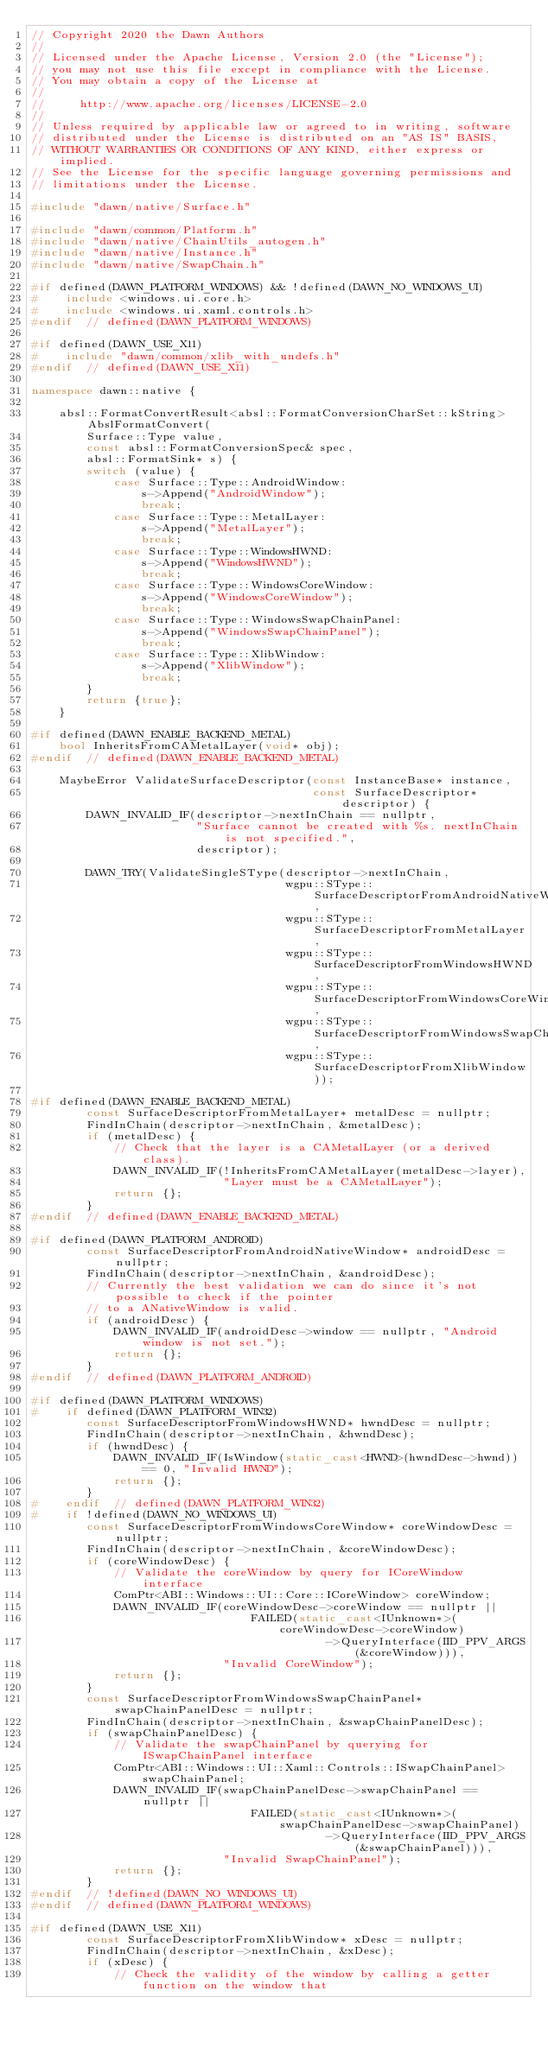Convert code to text. <code><loc_0><loc_0><loc_500><loc_500><_C++_>// Copyright 2020 the Dawn Authors
//
// Licensed under the Apache License, Version 2.0 (the "License");
// you may not use this file except in compliance with the License.
// You may obtain a copy of the License at
//
//     http://www.apache.org/licenses/LICENSE-2.0
//
// Unless required by applicable law or agreed to in writing, software
// distributed under the License is distributed on an "AS IS" BASIS,
// WITHOUT WARRANTIES OR CONDITIONS OF ANY KIND, either express or implied.
// See the License for the specific language governing permissions and
// limitations under the License.

#include "dawn/native/Surface.h"

#include "dawn/common/Platform.h"
#include "dawn/native/ChainUtils_autogen.h"
#include "dawn/native/Instance.h"
#include "dawn/native/SwapChain.h"

#if defined(DAWN_PLATFORM_WINDOWS) && !defined(DAWN_NO_WINDOWS_UI)
#    include <windows.ui.core.h>
#    include <windows.ui.xaml.controls.h>
#endif  // defined(DAWN_PLATFORM_WINDOWS)

#if defined(DAWN_USE_X11)
#    include "dawn/common/xlib_with_undefs.h"
#endif  // defined(DAWN_USE_X11)

namespace dawn::native {

    absl::FormatConvertResult<absl::FormatConversionCharSet::kString> AbslFormatConvert(
        Surface::Type value,
        const absl::FormatConversionSpec& spec,
        absl::FormatSink* s) {
        switch (value) {
            case Surface::Type::AndroidWindow:
                s->Append("AndroidWindow");
                break;
            case Surface::Type::MetalLayer:
                s->Append("MetalLayer");
                break;
            case Surface::Type::WindowsHWND:
                s->Append("WindowsHWND");
                break;
            case Surface::Type::WindowsCoreWindow:
                s->Append("WindowsCoreWindow");
                break;
            case Surface::Type::WindowsSwapChainPanel:
                s->Append("WindowsSwapChainPanel");
                break;
            case Surface::Type::XlibWindow:
                s->Append("XlibWindow");
                break;
        }
        return {true};
    }

#if defined(DAWN_ENABLE_BACKEND_METAL)
    bool InheritsFromCAMetalLayer(void* obj);
#endif  // defined(DAWN_ENABLE_BACKEND_METAL)

    MaybeError ValidateSurfaceDescriptor(const InstanceBase* instance,
                                         const SurfaceDescriptor* descriptor) {
        DAWN_INVALID_IF(descriptor->nextInChain == nullptr,
                        "Surface cannot be created with %s. nextInChain is not specified.",
                        descriptor);

        DAWN_TRY(ValidateSingleSType(descriptor->nextInChain,
                                     wgpu::SType::SurfaceDescriptorFromAndroidNativeWindow,
                                     wgpu::SType::SurfaceDescriptorFromMetalLayer,
                                     wgpu::SType::SurfaceDescriptorFromWindowsHWND,
                                     wgpu::SType::SurfaceDescriptorFromWindowsCoreWindow,
                                     wgpu::SType::SurfaceDescriptorFromWindowsSwapChainPanel,
                                     wgpu::SType::SurfaceDescriptorFromXlibWindow));

#if defined(DAWN_ENABLE_BACKEND_METAL)
        const SurfaceDescriptorFromMetalLayer* metalDesc = nullptr;
        FindInChain(descriptor->nextInChain, &metalDesc);
        if (metalDesc) {
            // Check that the layer is a CAMetalLayer (or a derived class).
            DAWN_INVALID_IF(!InheritsFromCAMetalLayer(metalDesc->layer),
                            "Layer must be a CAMetalLayer");
            return {};
        }
#endif  // defined(DAWN_ENABLE_BACKEND_METAL)

#if defined(DAWN_PLATFORM_ANDROID)
        const SurfaceDescriptorFromAndroidNativeWindow* androidDesc = nullptr;
        FindInChain(descriptor->nextInChain, &androidDesc);
        // Currently the best validation we can do since it's not possible to check if the pointer
        // to a ANativeWindow is valid.
        if (androidDesc) {
            DAWN_INVALID_IF(androidDesc->window == nullptr, "Android window is not set.");
            return {};
        }
#endif  // defined(DAWN_PLATFORM_ANDROID)

#if defined(DAWN_PLATFORM_WINDOWS)
#    if defined(DAWN_PLATFORM_WIN32)
        const SurfaceDescriptorFromWindowsHWND* hwndDesc = nullptr;
        FindInChain(descriptor->nextInChain, &hwndDesc);
        if (hwndDesc) {
            DAWN_INVALID_IF(IsWindow(static_cast<HWND>(hwndDesc->hwnd)) == 0, "Invalid HWND");
            return {};
        }
#    endif  // defined(DAWN_PLATFORM_WIN32)
#    if !defined(DAWN_NO_WINDOWS_UI)
        const SurfaceDescriptorFromWindowsCoreWindow* coreWindowDesc = nullptr;
        FindInChain(descriptor->nextInChain, &coreWindowDesc);
        if (coreWindowDesc) {
            // Validate the coreWindow by query for ICoreWindow interface
            ComPtr<ABI::Windows::UI::Core::ICoreWindow> coreWindow;
            DAWN_INVALID_IF(coreWindowDesc->coreWindow == nullptr ||
                                FAILED(static_cast<IUnknown*>(coreWindowDesc->coreWindow)
                                           ->QueryInterface(IID_PPV_ARGS(&coreWindow))),
                            "Invalid CoreWindow");
            return {};
        }
        const SurfaceDescriptorFromWindowsSwapChainPanel* swapChainPanelDesc = nullptr;
        FindInChain(descriptor->nextInChain, &swapChainPanelDesc);
        if (swapChainPanelDesc) {
            // Validate the swapChainPanel by querying for ISwapChainPanel interface
            ComPtr<ABI::Windows::UI::Xaml::Controls::ISwapChainPanel> swapChainPanel;
            DAWN_INVALID_IF(swapChainPanelDesc->swapChainPanel == nullptr ||
                                FAILED(static_cast<IUnknown*>(swapChainPanelDesc->swapChainPanel)
                                           ->QueryInterface(IID_PPV_ARGS(&swapChainPanel))),
                            "Invalid SwapChainPanel");
            return {};
        }
#endif  // !defined(DAWN_NO_WINDOWS_UI)
#endif  // defined(DAWN_PLATFORM_WINDOWS)

#if defined(DAWN_USE_X11)
        const SurfaceDescriptorFromXlibWindow* xDesc = nullptr;
        FindInChain(descriptor->nextInChain, &xDesc);
        if (xDesc) {
            // Check the validity of the window by calling a getter function on the window that</code> 